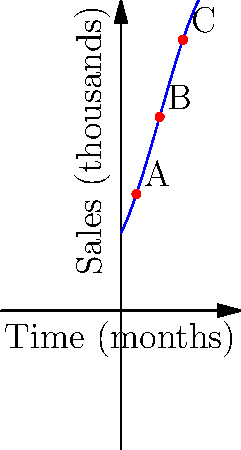A popular beauty influencer recently launched a new eyeshadow palette. The graph above represents the sales trend of this product over time, where the x-axis shows time in months and the y-axis shows sales in thousands of units. Based on the curve, which point (A, B, or C) likely represents the period when the influencer released a tutorial video featuring the palette, causing a surge in sales? To answer this question, we need to analyze the behavior of the polynomial function at different points:

1. Point A (around 2 months): The sales are increasing, but not at the highest rate.

2. Point B (around 5 months): This point shows the steepest increase in sales. The curve is at its most vertical here, indicating the fastest growth rate.

3. Point C (around 8 months): The sales are still increasing, but at a slower rate compared to point B. The curve is starting to flatten out.

In the context of beauty product sales and influencer marketing:

1. A sudden surge in sales is often associated with a significant event, such as a popular tutorial video or strong promotion.

2. This surge would typically cause a sharp increase in the sales curve, represented by the steepest part of the graph.

3. Point B shows the steepest increase, suggesting that this is when the sales growth was at its peak.

Therefore, point B is most likely to represent the period when the influencer released a tutorial video featuring the palette, causing a surge in sales.
Answer: B 